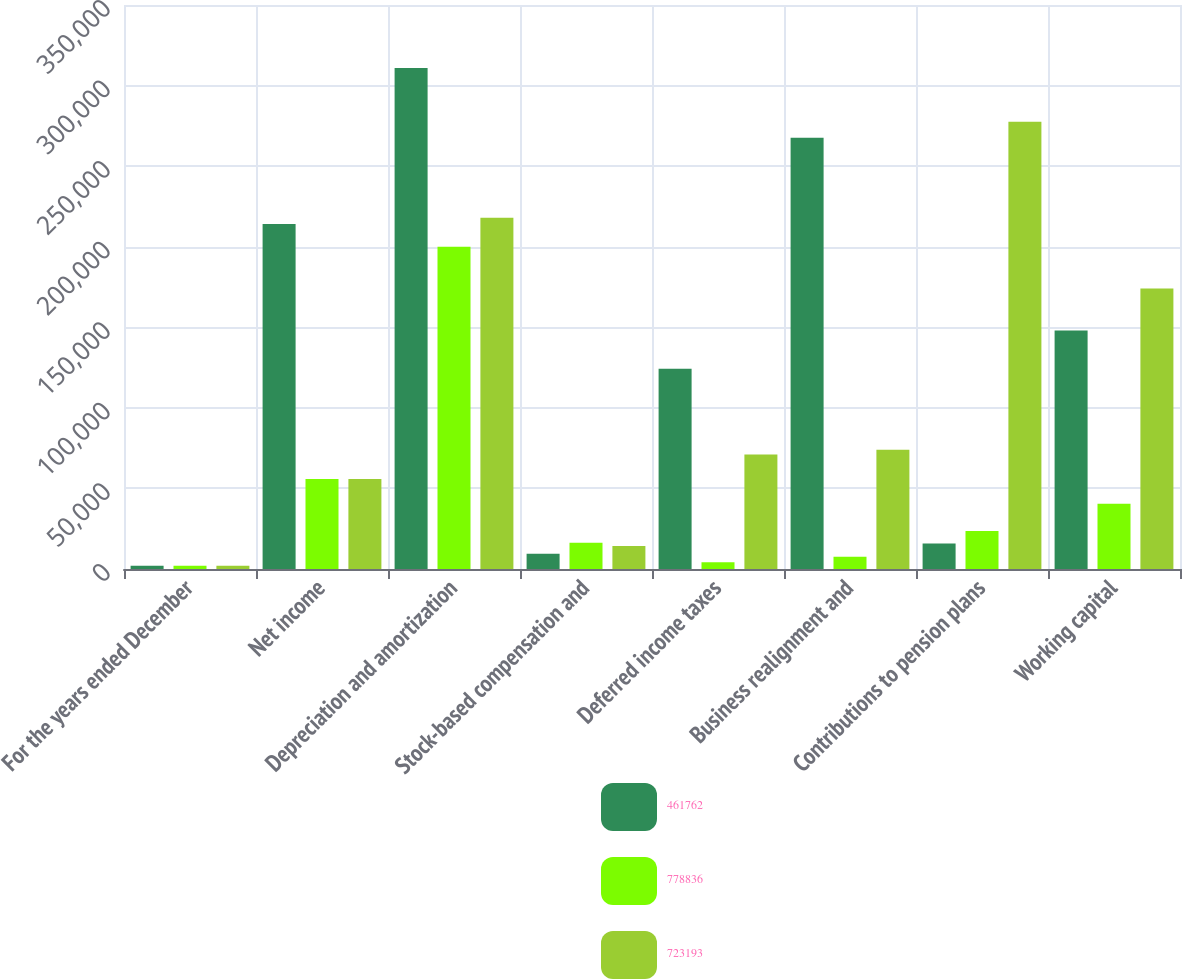<chart> <loc_0><loc_0><loc_500><loc_500><stacked_bar_chart><ecel><fcel>For the years ended December<fcel>Net income<fcel>Depreciation and amortization<fcel>Stock-based compensation and<fcel>Deferred income taxes<fcel>Business realignment and<fcel>Contributions to pension plans<fcel>Working capital<nl><fcel>461762<fcel>2007<fcel>214154<fcel>310925<fcel>9526<fcel>124276<fcel>267653<fcel>15836<fcel>148019<nl><fcel>778836<fcel>2006<fcel>55795.5<fcel>199911<fcel>16323<fcel>4173<fcel>7573<fcel>23570<fcel>40553<nl><fcel>723193<fcel>2005<fcel>55795.5<fcel>218032<fcel>14263<fcel>71038<fcel>74021<fcel>277492<fcel>174010<nl></chart> 